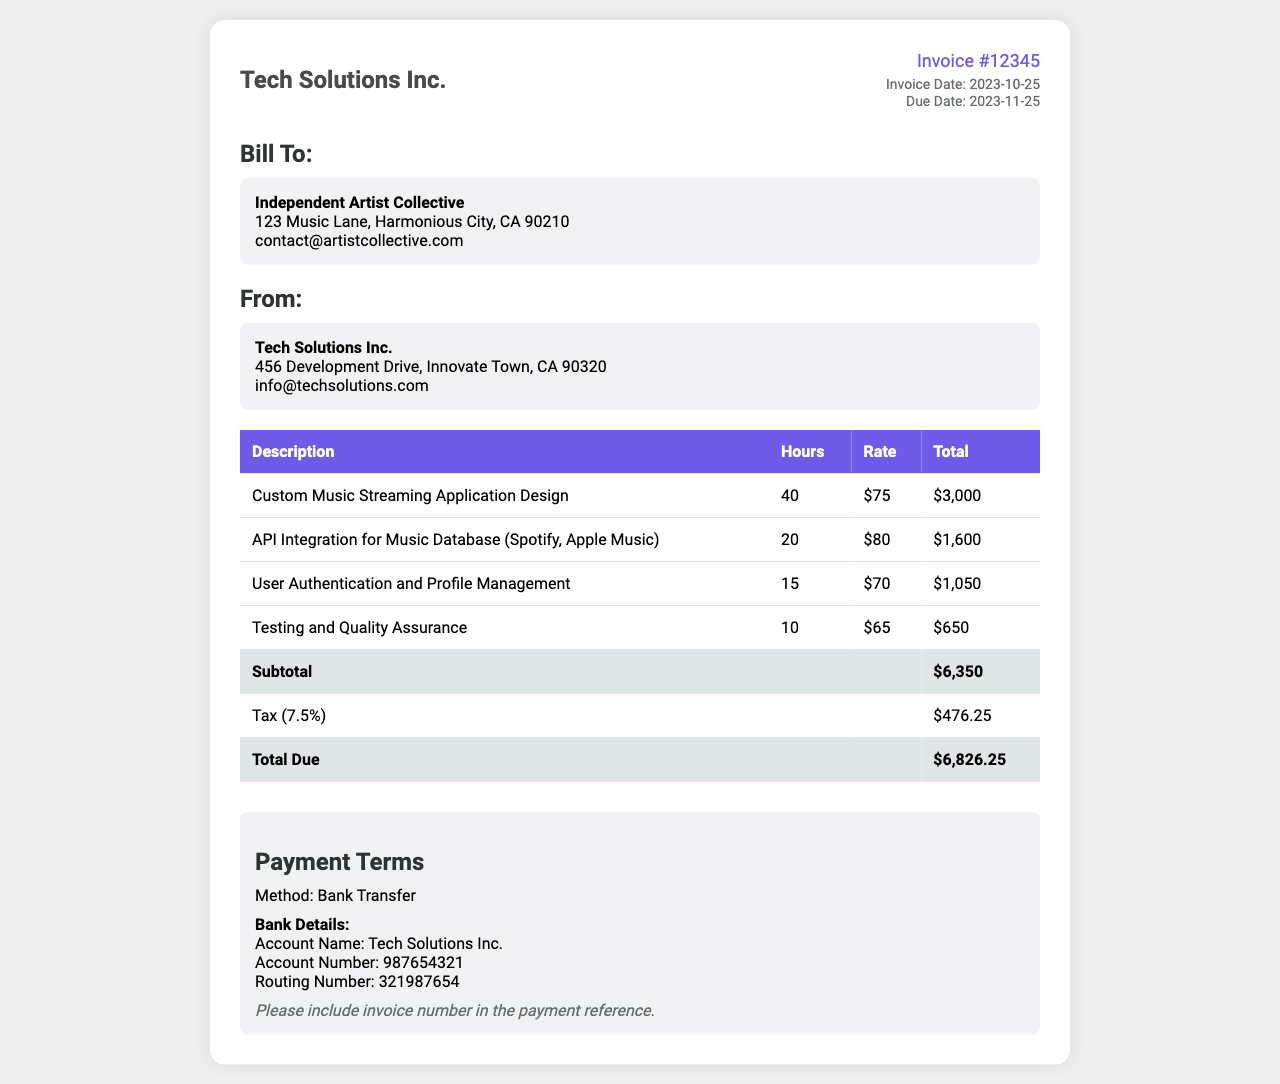What is the invoice number? The invoice number is a unique identifier for this document, indicated in the header section.
Answer: 12345 Who is billed in this invoice? The client information section specifies who the invoice is addressed to.
Answer: Independent Artist Collective What is the total due amount? The total due is calculated by summing the subtotal and tax.
Answer: $6,826.25 How many hours were worked for Custom Music Streaming Application Design? The hours worked are detailed in the service description table.
Answer: 40 What is the tax percentage applied? The tax percentage is explicitly mentioned in the invoice breakdown.
Answer: 7.5% What type of application is being developed? The invoice outlines the nature of the service being provided in the description section.
Answer: Music Streaming Application What is the hourly rate for User Authentication and Profile Management? The service rates for each task are provided in the service description table.
Answer: $70 Which service had the highest total cost? By comparing the total costs in the description table, you can identify the highest.
Answer: Custom Music Streaming Application Design What is the due date for this invoice? The due date is stated in the invoice details section which indicates when payment is expected.
Answer: 2023-11-25 